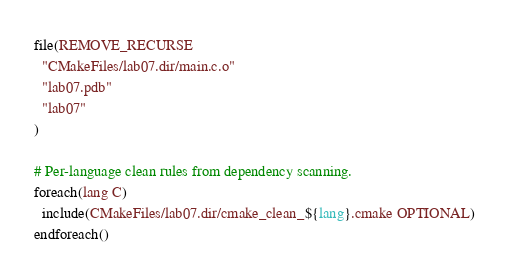Convert code to text. <code><loc_0><loc_0><loc_500><loc_500><_CMake_>file(REMOVE_RECURSE
  "CMakeFiles/lab07.dir/main.c.o"
  "lab07.pdb"
  "lab07"
)

# Per-language clean rules from dependency scanning.
foreach(lang C)
  include(CMakeFiles/lab07.dir/cmake_clean_${lang}.cmake OPTIONAL)
endforeach()
</code> 